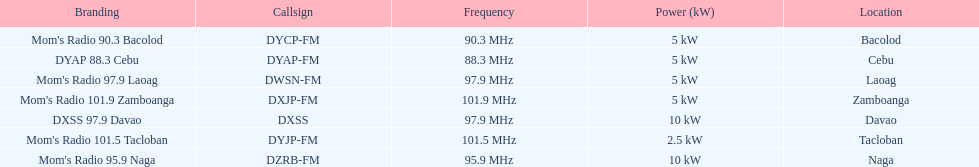What is the difference in kw between naga and bacolod radio? 5 kW. 